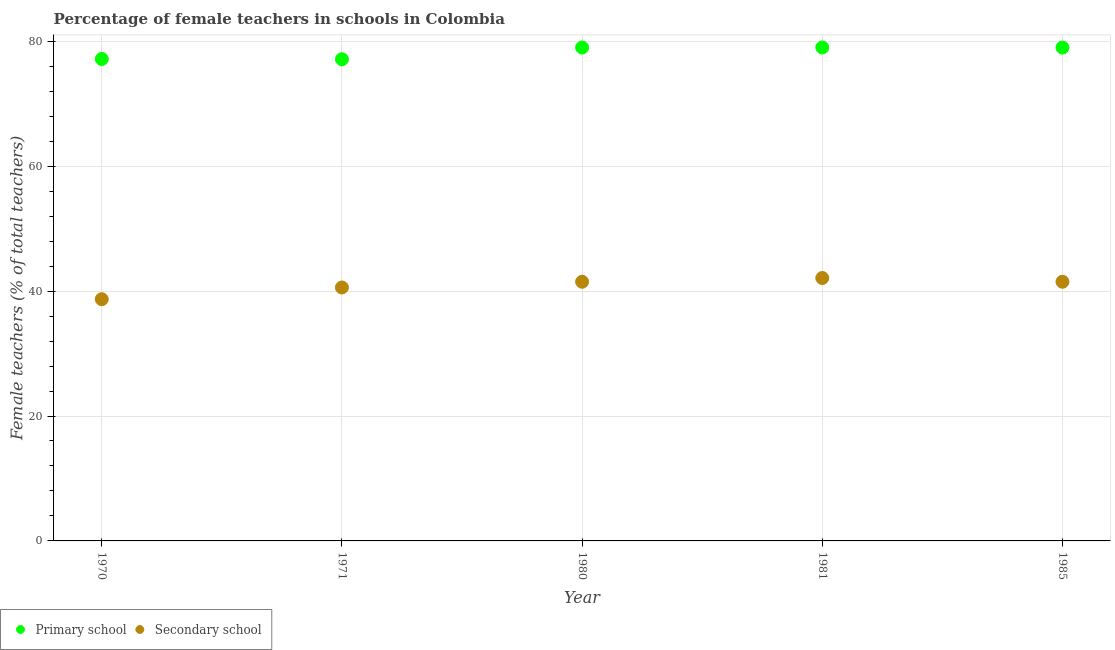What is the percentage of female teachers in primary schools in 1980?
Your answer should be compact. 79. Across all years, what is the maximum percentage of female teachers in primary schools?
Your answer should be very brief. 79.01. Across all years, what is the minimum percentage of female teachers in primary schools?
Ensure brevity in your answer.  77.13. In which year was the percentage of female teachers in primary schools maximum?
Keep it short and to the point. 1981. In which year was the percentage of female teachers in primary schools minimum?
Make the answer very short. 1971. What is the total percentage of female teachers in secondary schools in the graph?
Make the answer very short. 204.38. What is the difference between the percentage of female teachers in primary schools in 1980 and that in 1985?
Give a very brief answer. 0.01. What is the difference between the percentage of female teachers in primary schools in 1985 and the percentage of female teachers in secondary schools in 1970?
Make the answer very short. 40.29. What is the average percentage of female teachers in primary schools per year?
Provide a short and direct response. 78.26. In the year 1971, what is the difference between the percentage of female teachers in primary schools and percentage of female teachers in secondary schools?
Provide a short and direct response. 36.54. What is the ratio of the percentage of female teachers in primary schools in 1970 to that in 1980?
Keep it short and to the point. 0.98. What is the difference between the highest and the second highest percentage of female teachers in secondary schools?
Your answer should be compact. 0.6. What is the difference between the highest and the lowest percentage of female teachers in secondary schools?
Your response must be concise. 3.4. In how many years, is the percentage of female teachers in secondary schools greater than the average percentage of female teachers in secondary schools taken over all years?
Keep it short and to the point. 3. Is the sum of the percentage of female teachers in secondary schools in 1971 and 1980 greater than the maximum percentage of female teachers in primary schools across all years?
Ensure brevity in your answer.  Yes. Does the graph contain any zero values?
Provide a short and direct response. No. Does the graph contain grids?
Offer a very short reply. Yes. Where does the legend appear in the graph?
Provide a short and direct response. Bottom left. How many legend labels are there?
Provide a succinct answer. 2. How are the legend labels stacked?
Your response must be concise. Horizontal. What is the title of the graph?
Your response must be concise. Percentage of female teachers in schools in Colombia. What is the label or title of the Y-axis?
Offer a terse response. Female teachers (% of total teachers). What is the Female teachers (% of total teachers) of Primary school in 1970?
Ensure brevity in your answer.  77.17. What is the Female teachers (% of total teachers) of Secondary school in 1970?
Give a very brief answer. 38.7. What is the Female teachers (% of total teachers) of Primary school in 1971?
Your answer should be very brief. 77.13. What is the Female teachers (% of total teachers) in Secondary school in 1971?
Offer a terse response. 40.58. What is the Female teachers (% of total teachers) of Primary school in 1980?
Your answer should be compact. 79. What is the Female teachers (% of total teachers) in Secondary school in 1980?
Offer a very short reply. 41.5. What is the Female teachers (% of total teachers) in Primary school in 1981?
Provide a succinct answer. 79.01. What is the Female teachers (% of total teachers) of Secondary school in 1981?
Your answer should be compact. 42.1. What is the Female teachers (% of total teachers) of Primary school in 1985?
Keep it short and to the point. 78.99. What is the Female teachers (% of total teachers) of Secondary school in 1985?
Your answer should be very brief. 41.5. Across all years, what is the maximum Female teachers (% of total teachers) in Primary school?
Provide a succinct answer. 79.01. Across all years, what is the maximum Female teachers (% of total teachers) in Secondary school?
Offer a terse response. 42.1. Across all years, what is the minimum Female teachers (% of total teachers) of Primary school?
Your response must be concise. 77.13. Across all years, what is the minimum Female teachers (% of total teachers) of Secondary school?
Your response must be concise. 38.7. What is the total Female teachers (% of total teachers) of Primary school in the graph?
Give a very brief answer. 391.3. What is the total Female teachers (% of total teachers) in Secondary school in the graph?
Your response must be concise. 204.38. What is the difference between the Female teachers (% of total teachers) of Primary school in 1970 and that in 1971?
Your answer should be compact. 0.04. What is the difference between the Female teachers (% of total teachers) in Secondary school in 1970 and that in 1971?
Provide a short and direct response. -1.88. What is the difference between the Female teachers (% of total teachers) in Primary school in 1970 and that in 1980?
Keep it short and to the point. -1.83. What is the difference between the Female teachers (% of total teachers) in Secondary school in 1970 and that in 1980?
Make the answer very short. -2.8. What is the difference between the Female teachers (% of total teachers) of Primary school in 1970 and that in 1981?
Your answer should be compact. -1.84. What is the difference between the Female teachers (% of total teachers) of Secondary school in 1970 and that in 1981?
Offer a very short reply. -3.4. What is the difference between the Female teachers (% of total teachers) in Primary school in 1970 and that in 1985?
Ensure brevity in your answer.  -1.82. What is the difference between the Female teachers (% of total teachers) of Secondary school in 1970 and that in 1985?
Your answer should be compact. -2.8. What is the difference between the Female teachers (% of total teachers) of Primary school in 1971 and that in 1980?
Provide a short and direct response. -1.88. What is the difference between the Female teachers (% of total teachers) of Secondary school in 1971 and that in 1980?
Provide a succinct answer. -0.92. What is the difference between the Female teachers (% of total teachers) in Primary school in 1971 and that in 1981?
Offer a terse response. -1.89. What is the difference between the Female teachers (% of total teachers) of Secondary school in 1971 and that in 1981?
Ensure brevity in your answer.  -1.52. What is the difference between the Female teachers (% of total teachers) of Primary school in 1971 and that in 1985?
Keep it short and to the point. -1.87. What is the difference between the Female teachers (% of total teachers) in Secondary school in 1971 and that in 1985?
Provide a succinct answer. -0.92. What is the difference between the Female teachers (% of total teachers) of Primary school in 1980 and that in 1981?
Your answer should be compact. -0.01. What is the difference between the Female teachers (% of total teachers) in Secondary school in 1980 and that in 1981?
Ensure brevity in your answer.  -0.6. What is the difference between the Female teachers (% of total teachers) of Primary school in 1980 and that in 1985?
Offer a very short reply. 0.01. What is the difference between the Female teachers (% of total teachers) in Secondary school in 1980 and that in 1985?
Your response must be concise. 0. What is the difference between the Female teachers (% of total teachers) in Primary school in 1981 and that in 1985?
Ensure brevity in your answer.  0.02. What is the difference between the Female teachers (% of total teachers) of Secondary school in 1981 and that in 1985?
Give a very brief answer. 0.6. What is the difference between the Female teachers (% of total teachers) in Primary school in 1970 and the Female teachers (% of total teachers) in Secondary school in 1971?
Provide a succinct answer. 36.59. What is the difference between the Female teachers (% of total teachers) in Primary school in 1970 and the Female teachers (% of total teachers) in Secondary school in 1980?
Provide a succinct answer. 35.67. What is the difference between the Female teachers (% of total teachers) of Primary school in 1970 and the Female teachers (% of total teachers) of Secondary school in 1981?
Provide a succinct answer. 35.07. What is the difference between the Female teachers (% of total teachers) in Primary school in 1970 and the Female teachers (% of total teachers) in Secondary school in 1985?
Your answer should be compact. 35.67. What is the difference between the Female teachers (% of total teachers) of Primary school in 1971 and the Female teachers (% of total teachers) of Secondary school in 1980?
Your answer should be compact. 35.63. What is the difference between the Female teachers (% of total teachers) in Primary school in 1971 and the Female teachers (% of total teachers) in Secondary school in 1981?
Offer a very short reply. 35.03. What is the difference between the Female teachers (% of total teachers) in Primary school in 1971 and the Female teachers (% of total teachers) in Secondary school in 1985?
Keep it short and to the point. 35.63. What is the difference between the Female teachers (% of total teachers) in Primary school in 1980 and the Female teachers (% of total teachers) in Secondary school in 1981?
Your response must be concise. 36.9. What is the difference between the Female teachers (% of total teachers) of Primary school in 1980 and the Female teachers (% of total teachers) of Secondary school in 1985?
Keep it short and to the point. 37.5. What is the difference between the Female teachers (% of total teachers) in Primary school in 1981 and the Female teachers (% of total teachers) in Secondary school in 1985?
Provide a short and direct response. 37.51. What is the average Female teachers (% of total teachers) of Primary school per year?
Make the answer very short. 78.26. What is the average Female teachers (% of total teachers) of Secondary school per year?
Ensure brevity in your answer.  40.88. In the year 1970, what is the difference between the Female teachers (% of total teachers) of Primary school and Female teachers (% of total teachers) of Secondary school?
Your answer should be compact. 38.47. In the year 1971, what is the difference between the Female teachers (% of total teachers) of Primary school and Female teachers (% of total teachers) of Secondary school?
Provide a short and direct response. 36.54. In the year 1980, what is the difference between the Female teachers (% of total teachers) of Primary school and Female teachers (% of total teachers) of Secondary school?
Make the answer very short. 37.5. In the year 1981, what is the difference between the Female teachers (% of total teachers) in Primary school and Female teachers (% of total teachers) in Secondary school?
Keep it short and to the point. 36.91. In the year 1985, what is the difference between the Female teachers (% of total teachers) in Primary school and Female teachers (% of total teachers) in Secondary school?
Offer a terse response. 37.49. What is the ratio of the Female teachers (% of total teachers) of Secondary school in 1970 to that in 1971?
Make the answer very short. 0.95. What is the ratio of the Female teachers (% of total teachers) in Primary school in 1970 to that in 1980?
Offer a terse response. 0.98. What is the ratio of the Female teachers (% of total teachers) in Secondary school in 1970 to that in 1980?
Your answer should be very brief. 0.93. What is the ratio of the Female teachers (% of total teachers) of Primary school in 1970 to that in 1981?
Give a very brief answer. 0.98. What is the ratio of the Female teachers (% of total teachers) of Secondary school in 1970 to that in 1981?
Offer a very short reply. 0.92. What is the ratio of the Female teachers (% of total teachers) of Primary school in 1970 to that in 1985?
Give a very brief answer. 0.98. What is the ratio of the Female teachers (% of total teachers) in Secondary school in 1970 to that in 1985?
Provide a succinct answer. 0.93. What is the ratio of the Female teachers (% of total teachers) in Primary school in 1971 to that in 1980?
Give a very brief answer. 0.98. What is the ratio of the Female teachers (% of total teachers) in Secondary school in 1971 to that in 1980?
Ensure brevity in your answer.  0.98. What is the ratio of the Female teachers (% of total teachers) of Primary school in 1971 to that in 1981?
Provide a short and direct response. 0.98. What is the ratio of the Female teachers (% of total teachers) of Secondary school in 1971 to that in 1981?
Your answer should be very brief. 0.96. What is the ratio of the Female teachers (% of total teachers) of Primary school in 1971 to that in 1985?
Make the answer very short. 0.98. What is the ratio of the Female teachers (% of total teachers) in Secondary school in 1971 to that in 1985?
Offer a terse response. 0.98. What is the ratio of the Female teachers (% of total teachers) of Secondary school in 1980 to that in 1981?
Ensure brevity in your answer.  0.99. What is the ratio of the Female teachers (% of total teachers) in Primary school in 1981 to that in 1985?
Make the answer very short. 1. What is the ratio of the Female teachers (% of total teachers) of Secondary school in 1981 to that in 1985?
Give a very brief answer. 1.01. What is the difference between the highest and the second highest Female teachers (% of total teachers) of Primary school?
Your answer should be compact. 0.01. What is the difference between the highest and the second highest Female teachers (% of total teachers) in Secondary school?
Your response must be concise. 0.6. What is the difference between the highest and the lowest Female teachers (% of total teachers) in Primary school?
Offer a very short reply. 1.89. What is the difference between the highest and the lowest Female teachers (% of total teachers) of Secondary school?
Offer a very short reply. 3.4. 